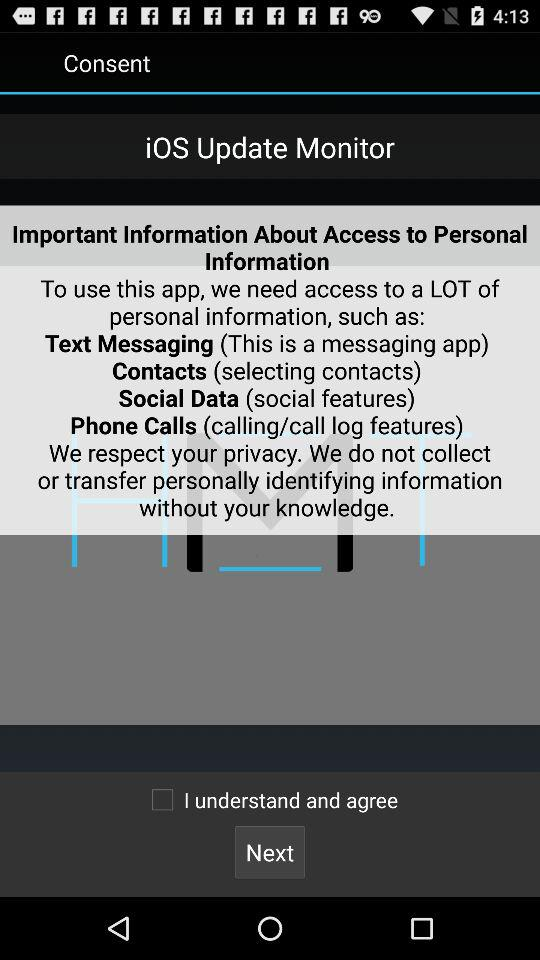What is the name of the application? The name of the application is "iOS Update Monitor". 